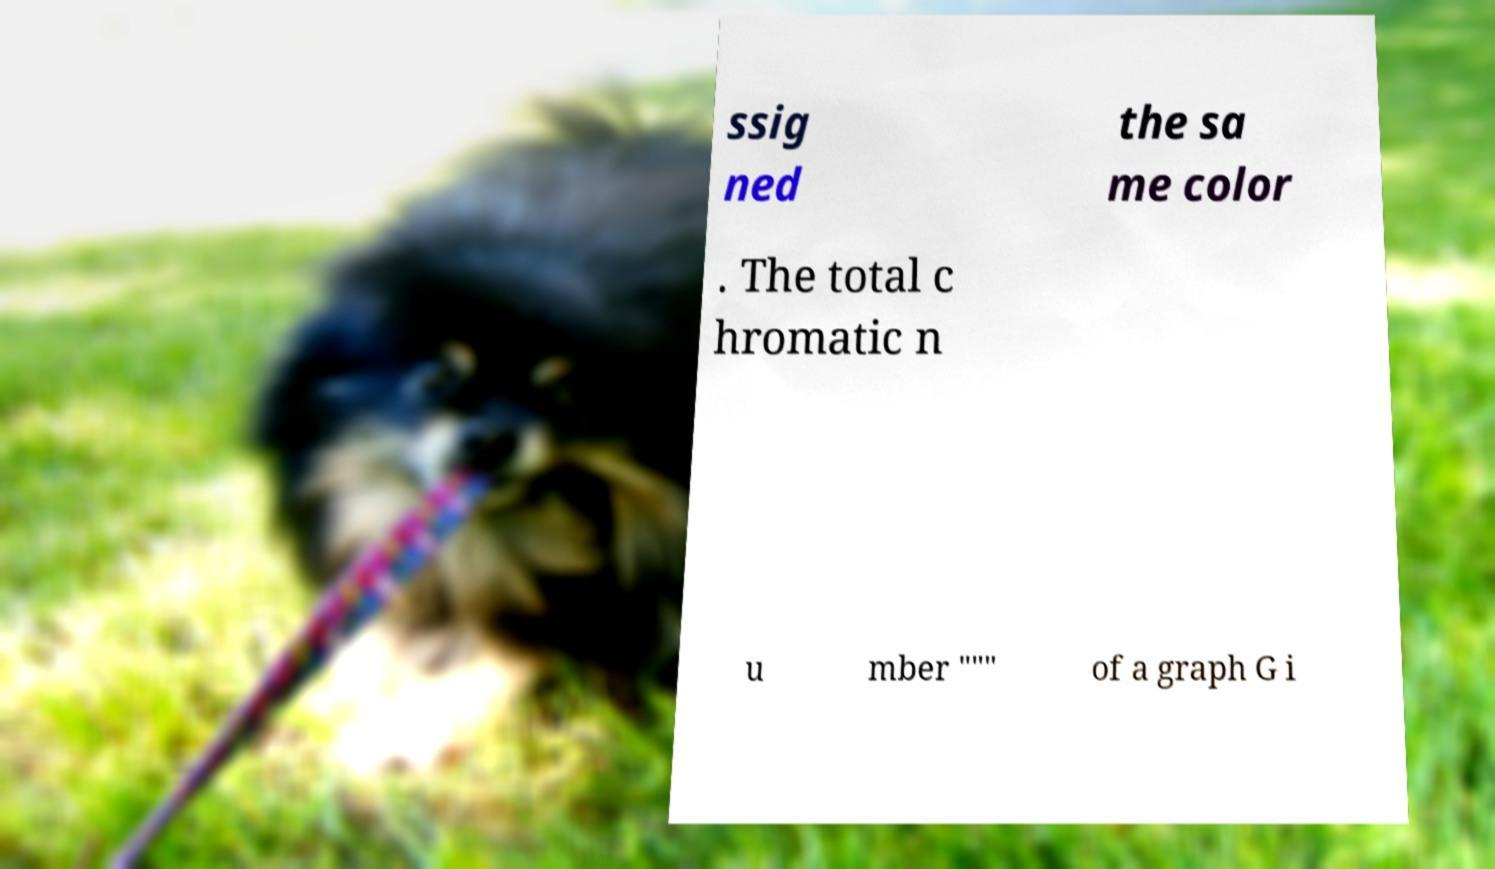I need the written content from this picture converted into text. Can you do that? ssig ned the sa me color . The total c hromatic n u mber "″" of a graph G i 